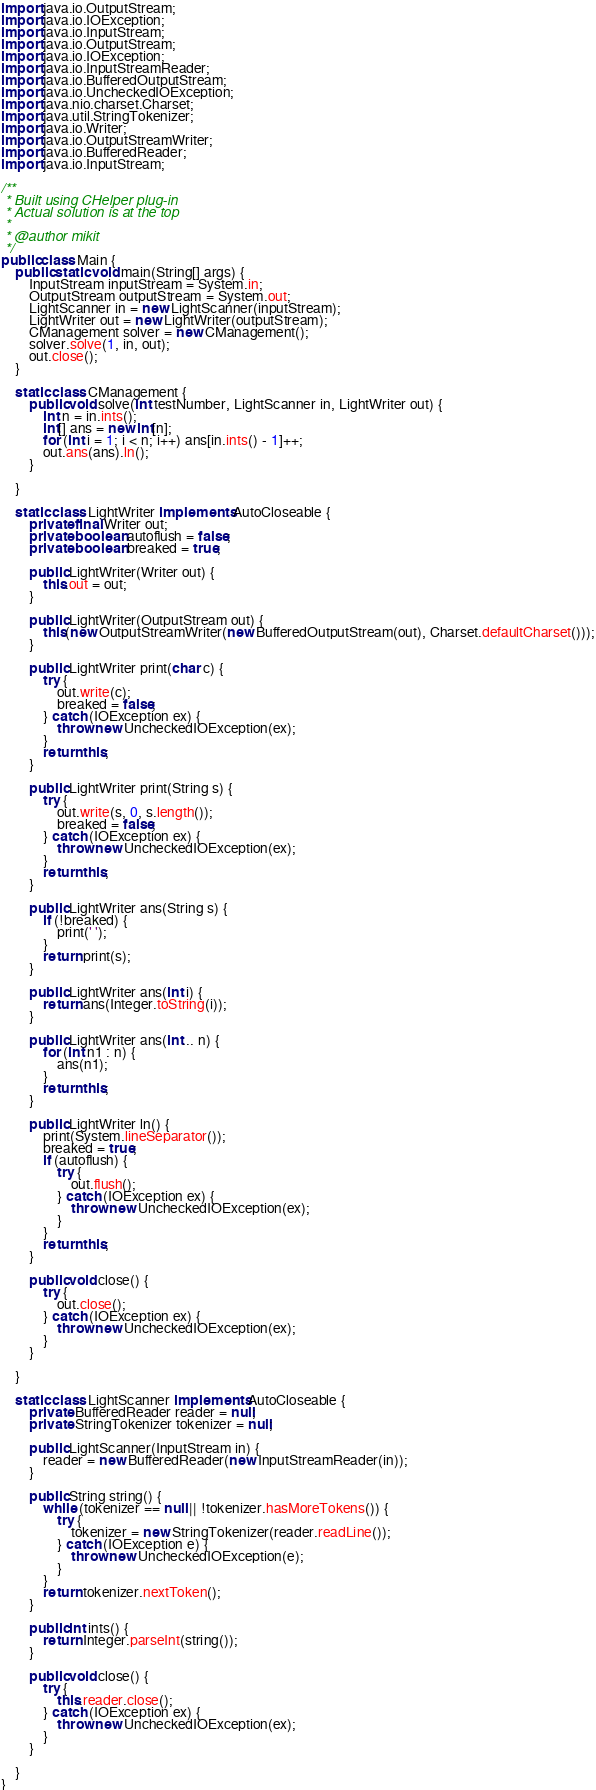Convert code to text. <code><loc_0><loc_0><loc_500><loc_500><_Java_>import java.io.OutputStream;
import java.io.IOException;
import java.io.InputStream;
import java.io.OutputStream;
import java.io.IOException;
import java.io.InputStreamReader;
import java.io.BufferedOutputStream;
import java.io.UncheckedIOException;
import java.nio.charset.Charset;
import java.util.StringTokenizer;
import java.io.Writer;
import java.io.OutputStreamWriter;
import java.io.BufferedReader;
import java.io.InputStream;

/**
 * Built using CHelper plug-in
 * Actual solution is at the top
 *
 * @author mikit
 */
public class Main {
    public static void main(String[] args) {
        InputStream inputStream = System.in;
        OutputStream outputStream = System.out;
        LightScanner in = new LightScanner(inputStream);
        LightWriter out = new LightWriter(outputStream);
        CManagement solver = new CManagement();
        solver.solve(1, in, out);
        out.close();
    }

    static class CManagement {
        public void solve(int testNumber, LightScanner in, LightWriter out) {
            int n = in.ints();
            int[] ans = new int[n];
            for (int i = 1; i < n; i++) ans[in.ints() - 1]++;
            out.ans(ans).ln();
        }

    }

    static class LightWriter implements AutoCloseable {
        private final Writer out;
        private boolean autoflush = false;
        private boolean breaked = true;

        public LightWriter(Writer out) {
            this.out = out;
        }

        public LightWriter(OutputStream out) {
            this(new OutputStreamWriter(new BufferedOutputStream(out), Charset.defaultCharset()));
        }

        public LightWriter print(char c) {
            try {
                out.write(c);
                breaked = false;
            } catch (IOException ex) {
                throw new UncheckedIOException(ex);
            }
            return this;
        }

        public LightWriter print(String s) {
            try {
                out.write(s, 0, s.length());
                breaked = false;
            } catch (IOException ex) {
                throw new UncheckedIOException(ex);
            }
            return this;
        }

        public LightWriter ans(String s) {
            if (!breaked) {
                print(' ');
            }
            return print(s);
        }

        public LightWriter ans(int i) {
            return ans(Integer.toString(i));
        }

        public LightWriter ans(int... n) {
            for (int n1 : n) {
                ans(n1);
            }
            return this;
        }

        public LightWriter ln() {
            print(System.lineSeparator());
            breaked = true;
            if (autoflush) {
                try {
                    out.flush();
                } catch (IOException ex) {
                    throw new UncheckedIOException(ex);
                }
            }
            return this;
        }

        public void close() {
            try {
                out.close();
            } catch (IOException ex) {
                throw new UncheckedIOException(ex);
            }
        }

    }

    static class LightScanner implements AutoCloseable {
        private BufferedReader reader = null;
        private StringTokenizer tokenizer = null;

        public LightScanner(InputStream in) {
            reader = new BufferedReader(new InputStreamReader(in));
        }

        public String string() {
            while (tokenizer == null || !tokenizer.hasMoreTokens()) {
                try {
                    tokenizer = new StringTokenizer(reader.readLine());
                } catch (IOException e) {
                    throw new UncheckedIOException(e);
                }
            }
            return tokenizer.nextToken();
        }

        public int ints() {
            return Integer.parseInt(string());
        }

        public void close() {
            try {
                this.reader.close();
            } catch (IOException ex) {
                throw new UncheckedIOException(ex);
            }
        }

    }
}

</code> 